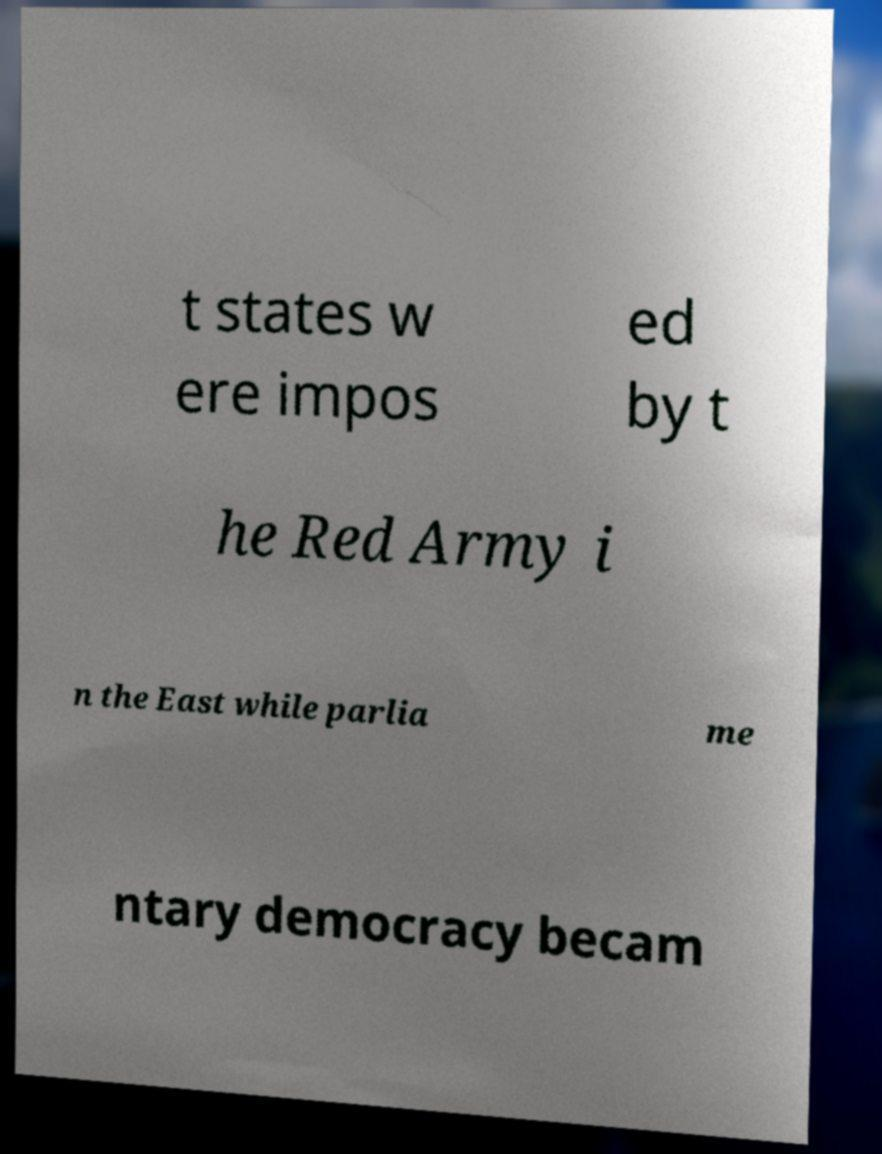Could you extract and type out the text from this image? t states w ere impos ed by t he Red Army i n the East while parlia me ntary democracy becam 